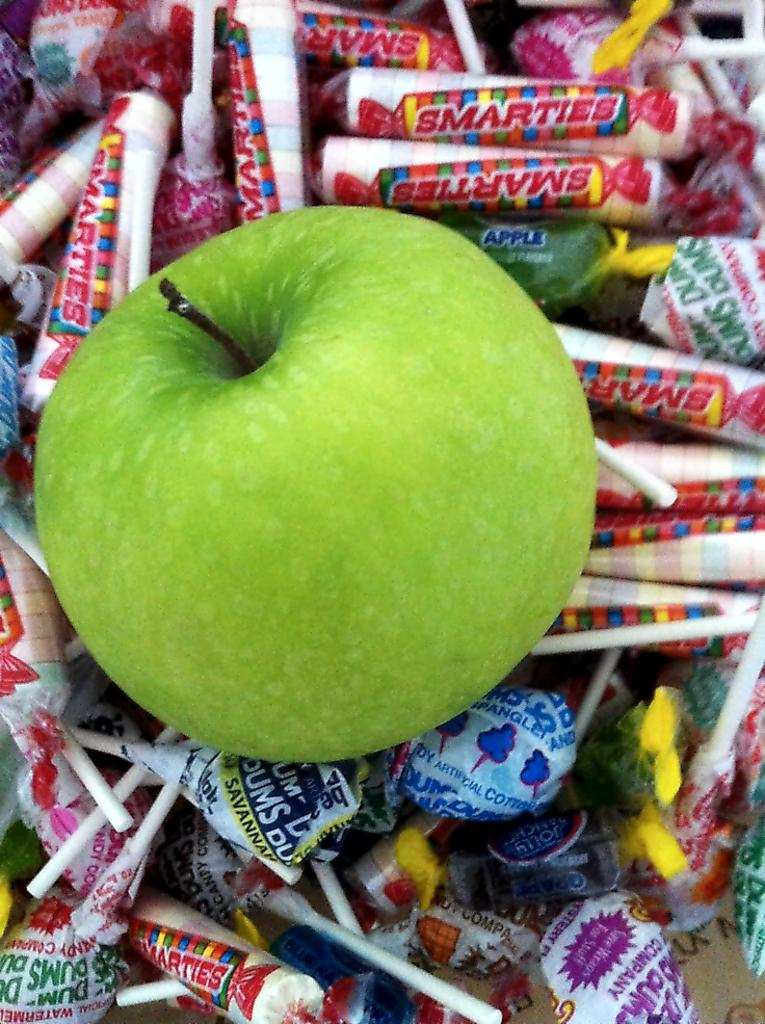What type of fruit is in the image? There is a green apple in the image. What type of candy is in the image? There are lollipops in the image. What other food items can be seen in the image? There are other food items in the image, but their specific types are not mentioned in the provided facts. What type of science is being conducted in the image? There is no indication of any scientific activity in the image. 